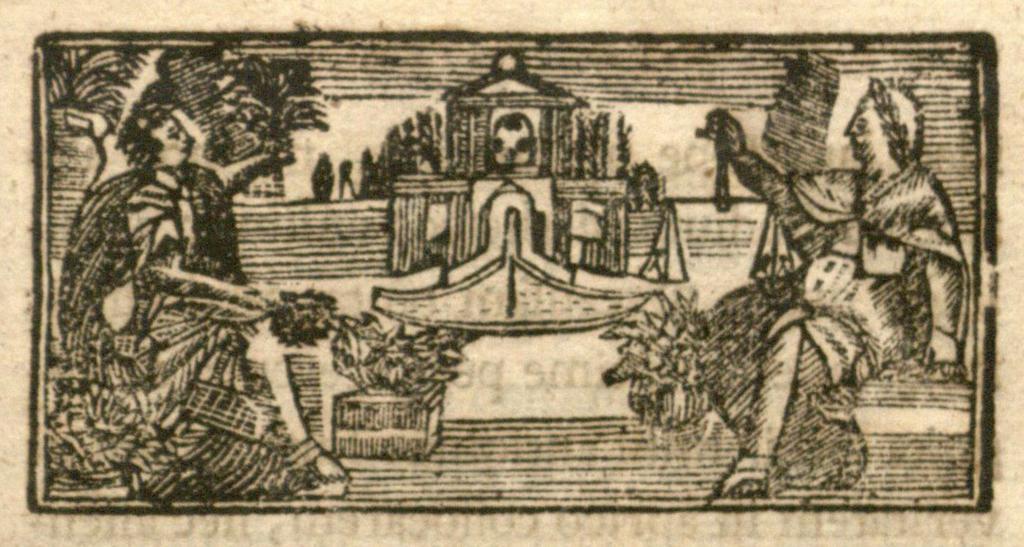Can you describe this image briefly? In this image we can see a drawing, there are two people one on the left side and one on the right side. 